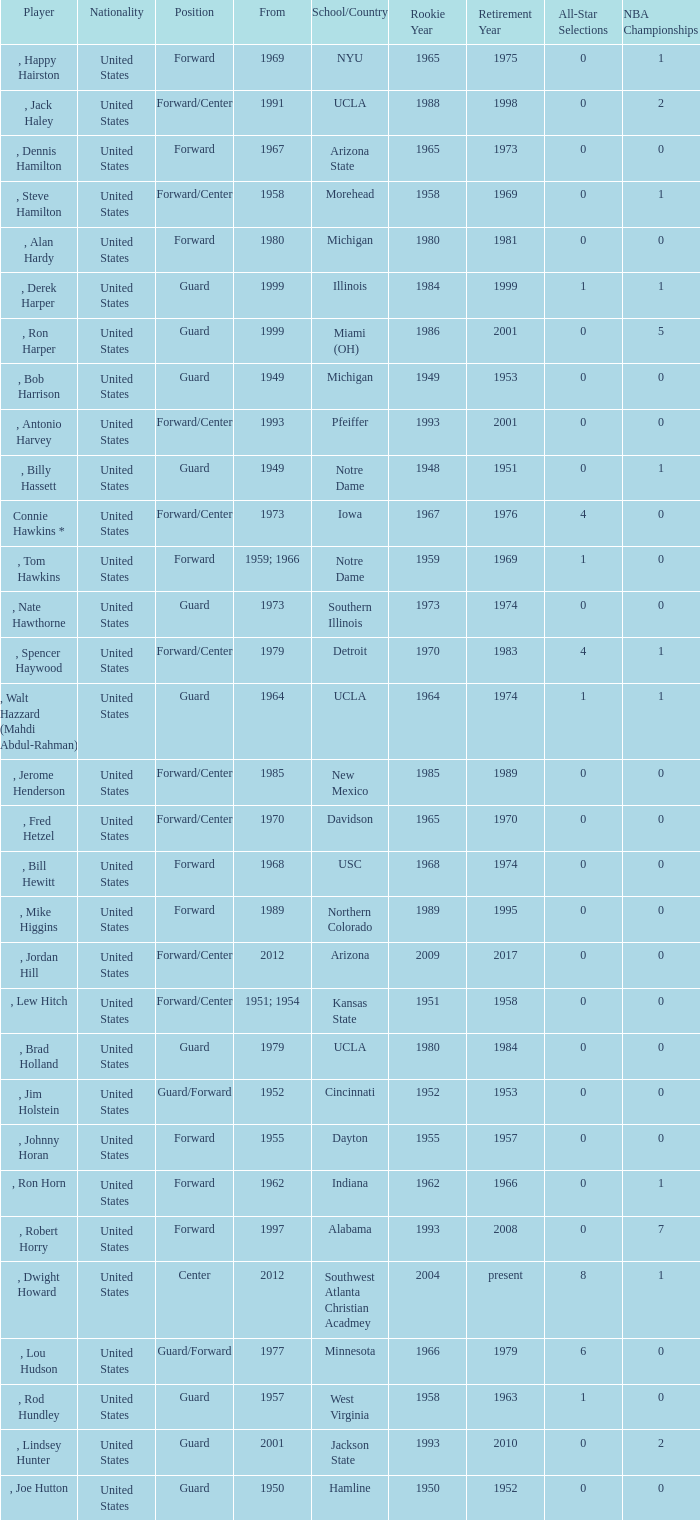Which player started in 2001? , Lindsey Hunter. 